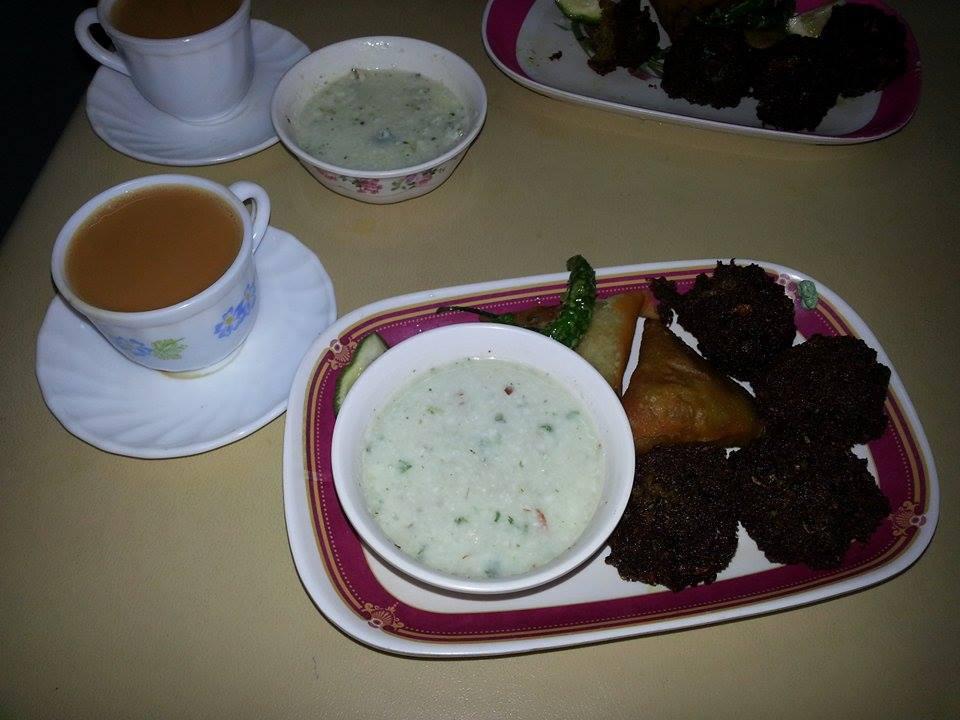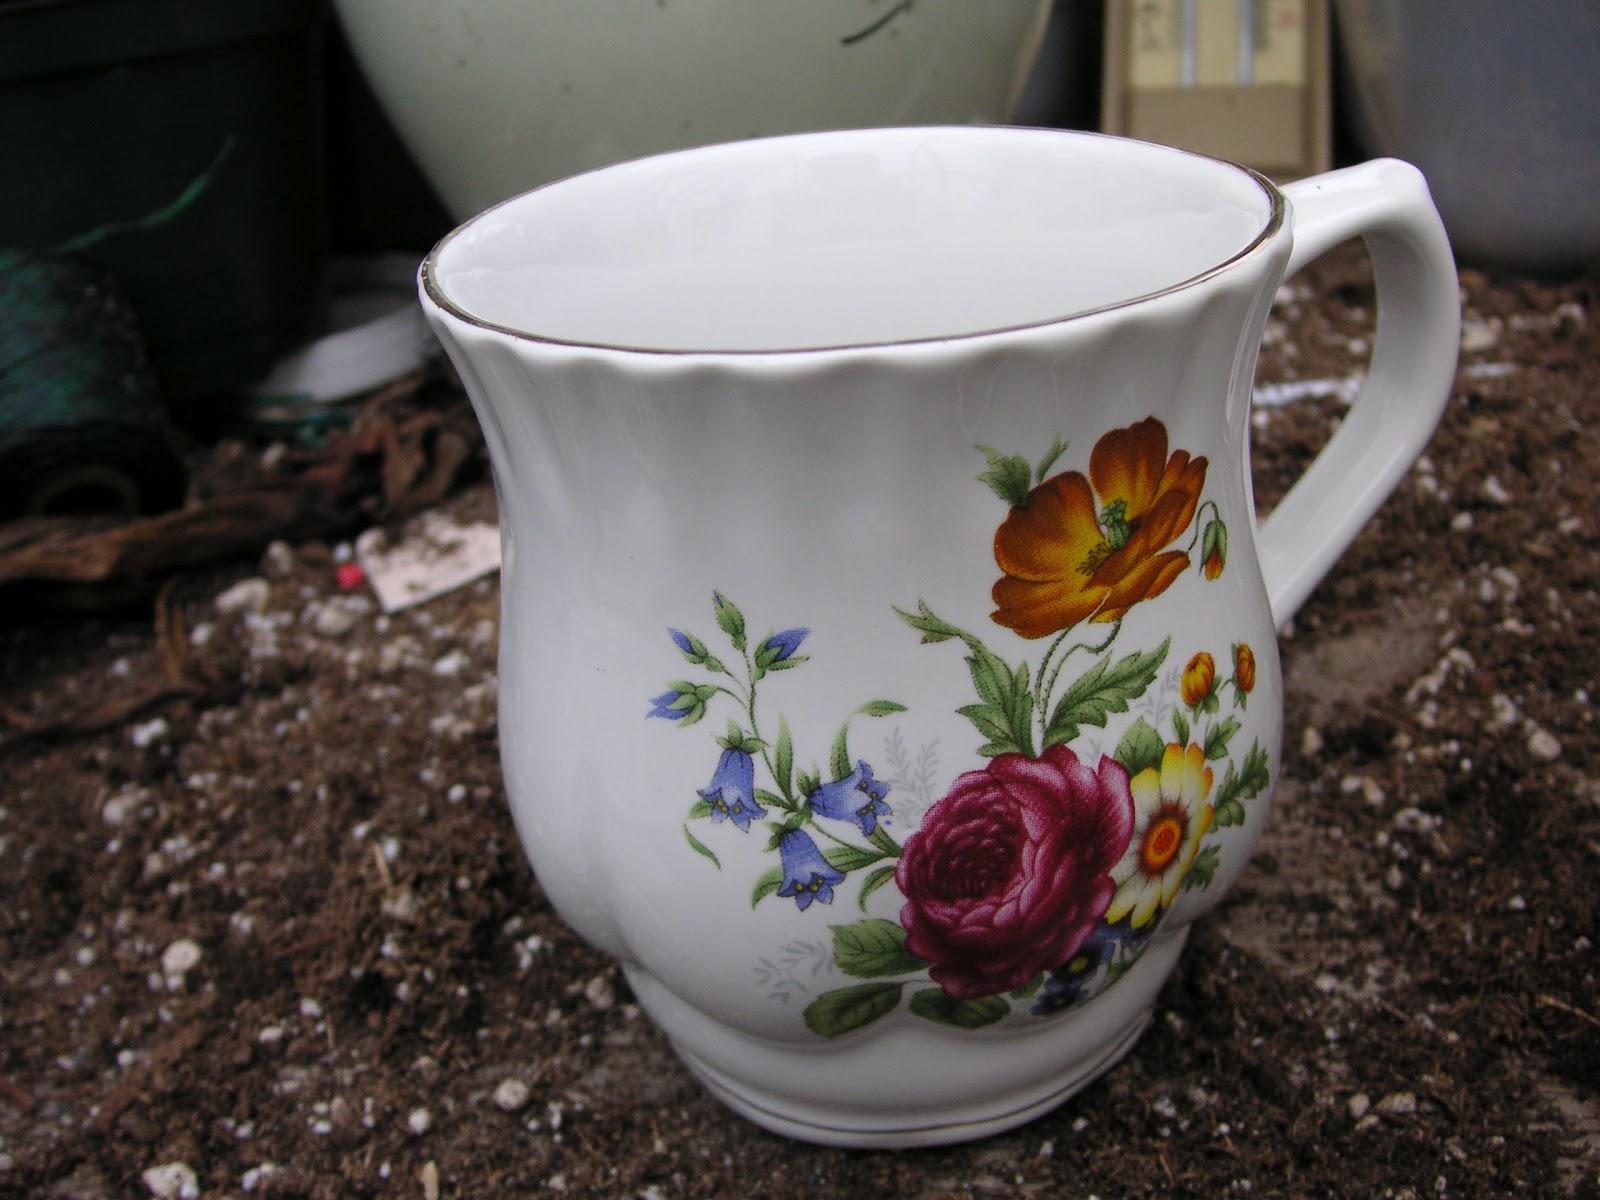The first image is the image on the left, the second image is the image on the right. Examine the images to the left and right. Is the description "Any cups in the left image are solid white and any cups in the right image are not solid white." accurate? Answer yes or no. No. The first image is the image on the left, the second image is the image on the right. Examine the images to the left and right. Is the description "The right image includes a porcelain cup with flowers on it sitting on a saucer in front of a container with a spout." accurate? Answer yes or no. No. 